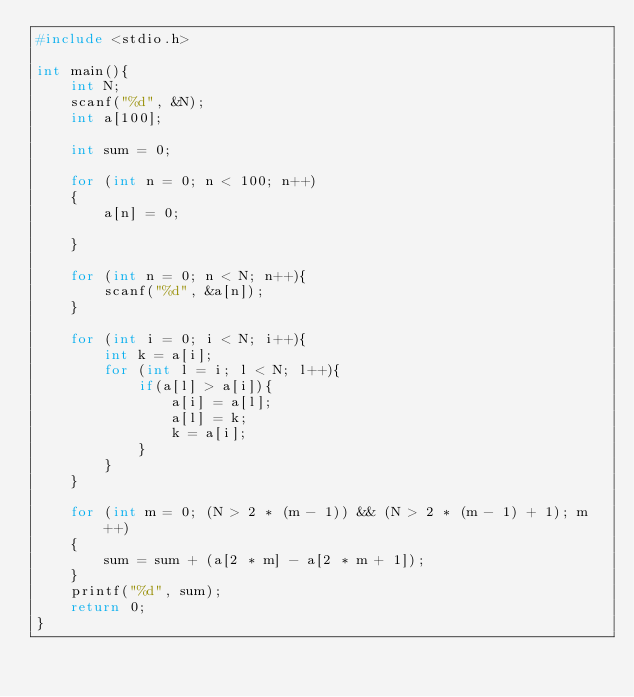Convert code to text. <code><loc_0><loc_0><loc_500><loc_500><_C_>#include <stdio.h>

int main(){
    int N;
    scanf("%d", &N);
    int a[100];

    int sum = 0;

    for (int n = 0; n < 100; n++)
    {
        a[n] = 0;

    }

    for (int n = 0; n < N; n++){
        scanf("%d", &a[n]);
    }

    for (int i = 0; i < N; i++){
        int k = a[i];
        for (int l = i; l < N; l++){
            if(a[l] > a[i]){
                a[i] = a[l];
                a[l] = k;
                k = a[i];
            }
        }
    }

    for (int m = 0; (N > 2 * (m - 1)) && (N > 2 * (m - 1) + 1); m++)
    {
        sum = sum + (a[2 * m] - a[2 * m + 1]);
    }
    printf("%d", sum);
    return 0;
}</code> 